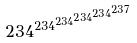<formula> <loc_0><loc_0><loc_500><loc_500>2 3 4 ^ { 2 3 4 ^ { 2 3 4 ^ { 2 3 4 ^ { 2 3 4 ^ { 2 3 7 } } } } }</formula> 